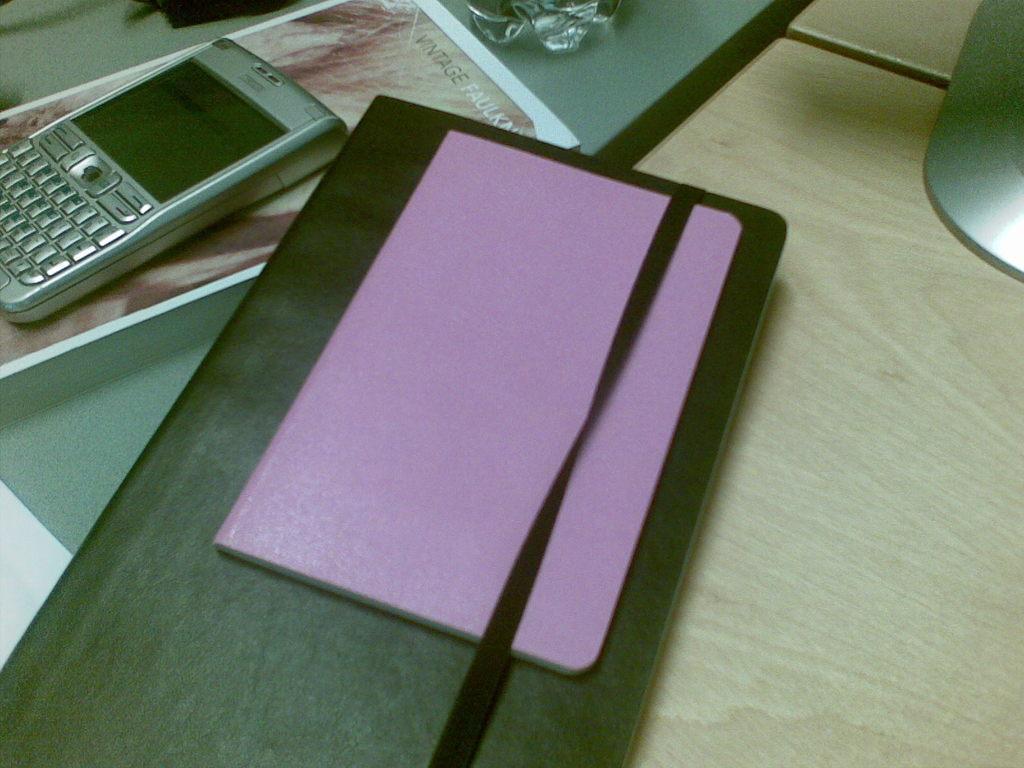What is the color of the table in the image? The table in the image is brown. What objects are on the table? There is a black file, a purple book, and a cell phone on the table. What type of plastic is used to make the pan in the image? There is no pan present in the image, so it is not possible to determine the type of plastic used to make it. 